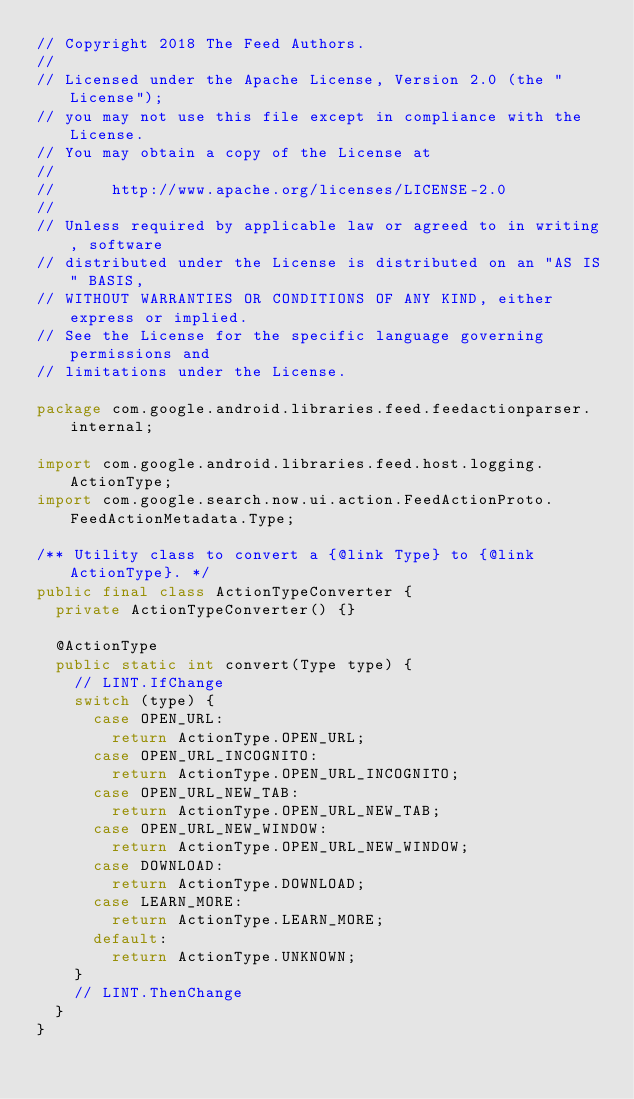Convert code to text. <code><loc_0><loc_0><loc_500><loc_500><_Java_>// Copyright 2018 The Feed Authors.
//
// Licensed under the Apache License, Version 2.0 (the "License");
// you may not use this file except in compliance with the License.
// You may obtain a copy of the License at
//
//      http://www.apache.org/licenses/LICENSE-2.0
//
// Unless required by applicable law or agreed to in writing, software
// distributed under the License is distributed on an "AS IS" BASIS,
// WITHOUT WARRANTIES OR CONDITIONS OF ANY KIND, either express or implied.
// See the License for the specific language governing permissions and
// limitations under the License.

package com.google.android.libraries.feed.feedactionparser.internal;

import com.google.android.libraries.feed.host.logging.ActionType;
import com.google.search.now.ui.action.FeedActionProto.FeedActionMetadata.Type;

/** Utility class to convert a {@link Type} to {@link ActionType}. */
public final class ActionTypeConverter {
  private ActionTypeConverter() {}

  @ActionType
  public static int convert(Type type) {
    // LINT.IfChange
    switch (type) {
      case OPEN_URL:
        return ActionType.OPEN_URL;
      case OPEN_URL_INCOGNITO:
        return ActionType.OPEN_URL_INCOGNITO;
      case OPEN_URL_NEW_TAB:
        return ActionType.OPEN_URL_NEW_TAB;
      case OPEN_URL_NEW_WINDOW:
        return ActionType.OPEN_URL_NEW_WINDOW;
      case DOWNLOAD:
        return ActionType.DOWNLOAD;
      case LEARN_MORE:
        return ActionType.LEARN_MORE;
      default:
        return ActionType.UNKNOWN;
    }
    // LINT.ThenChange
  }
}
</code> 